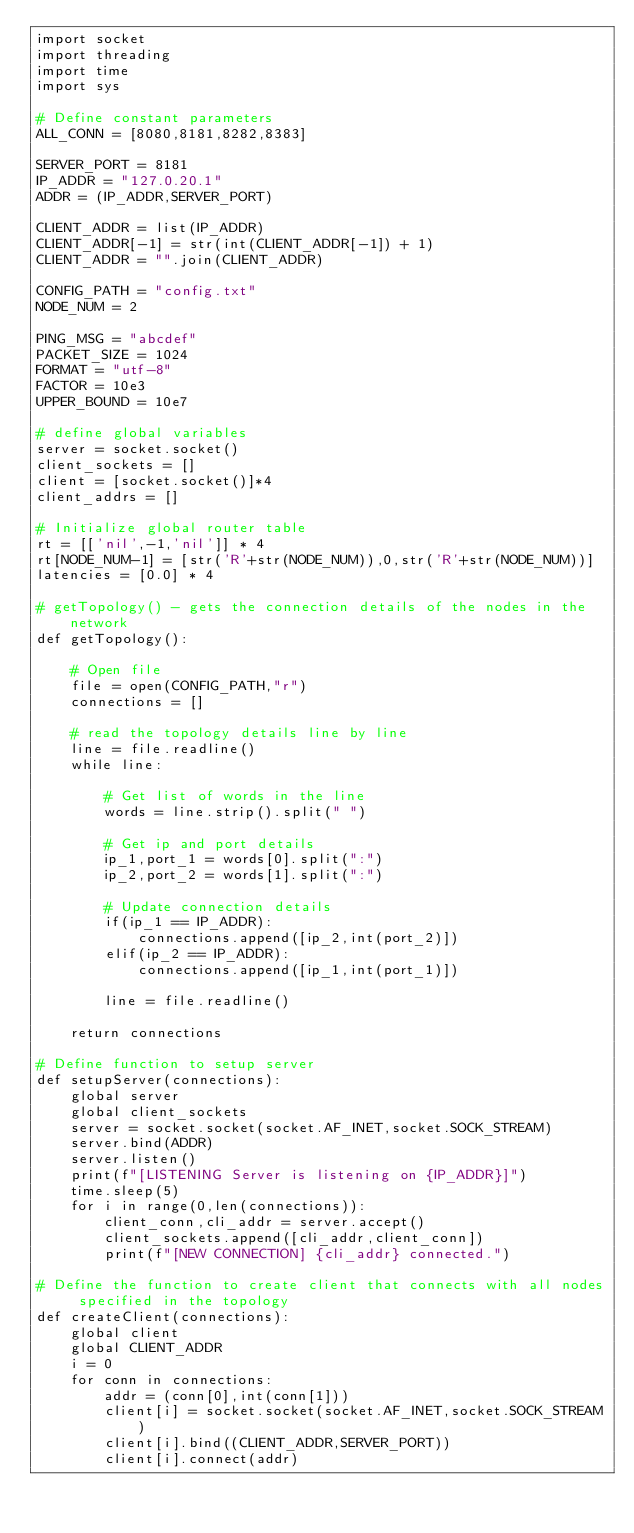Convert code to text. <code><loc_0><loc_0><loc_500><loc_500><_Python_>import socket
import threading
import time
import sys

# Define constant parameters
ALL_CONN = [8080,8181,8282,8383]

SERVER_PORT = 8181
IP_ADDR = "127.0.20.1"
ADDR = (IP_ADDR,SERVER_PORT)

CLIENT_ADDR = list(IP_ADDR)
CLIENT_ADDR[-1] = str(int(CLIENT_ADDR[-1]) + 1)
CLIENT_ADDR = "".join(CLIENT_ADDR)

CONFIG_PATH = "config.txt"
NODE_NUM = 2

PING_MSG = "abcdef"
PACKET_SIZE = 1024
FORMAT = "utf-8"
FACTOR = 10e3
UPPER_BOUND = 10e7

# define global variables
server = socket.socket()
client_sockets = []
client = [socket.socket()]*4
client_addrs = []

# Initialize global router table
rt = [['nil',-1,'nil']] * 4
rt[NODE_NUM-1] = [str('R'+str(NODE_NUM)),0,str('R'+str(NODE_NUM))]
latencies = [0.0] * 4

# getTopology() - gets the connection details of the nodes in the network
def getTopology():

	# Open file 
	file = open(CONFIG_PATH,"r")
	connections = []

	# read the topology details line by line
	line = file.readline()
	while line:

		# Get list of words in the line
		words = line.strip().split(" ")

		# Get ip and port details
		ip_1,port_1 = words[0].split(":")
		ip_2,port_2 = words[1].split(":")

		# Update connection details
		if(ip_1 == IP_ADDR):
			connections.append([ip_2,int(port_2)])
		elif(ip_2 == IP_ADDR):
			connections.append([ip_1,int(port_1)])

		line = file.readline()

	return connections

# Define function to setup server
def setupServer(connections):
	global server
	global client_sockets
	server = socket.socket(socket.AF_INET,socket.SOCK_STREAM)
	server.bind(ADDR)
	server.listen()
	print(f"[LISTENING Server is listening on {IP_ADDR}]")
	time.sleep(5)
	for i in range(0,len(connections)):
		client_conn,cli_addr = server.accept()
		client_sockets.append([cli_addr,client_conn])
		print(f"[NEW CONNECTION] {cli_addr} connected.")

# Define the function to create client that connects with all nodes specified in the topology
def createClient(connections):
	global client
	global CLIENT_ADDR
	i = 0
	for conn in connections:
		addr = (conn[0],int(conn[1]))
		client[i] = socket.socket(socket.AF_INET,socket.SOCK_STREAM)
		client[i].bind((CLIENT_ADDR,SERVER_PORT))
		client[i].connect(addr)</code> 